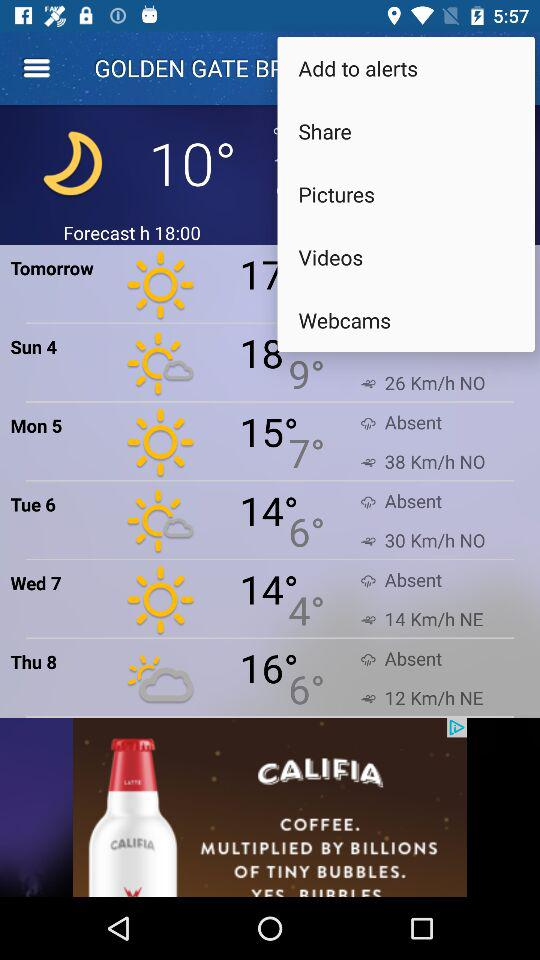What's the forecast hour? The forecast hour is 18:00. 